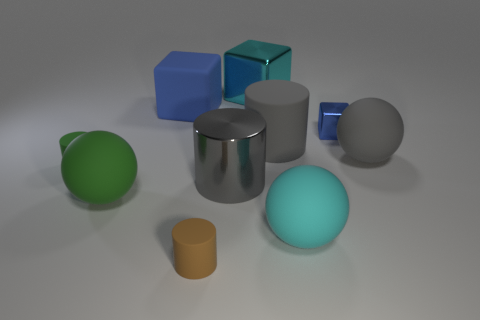Subtract all rubber cylinders. How many cylinders are left? 1 Subtract all green cylinders. How many cylinders are left? 3 Subtract all spheres. How many objects are left? 7 Subtract all purple blocks. How many cyan cylinders are left? 0 Subtract all rubber cubes. Subtract all big shiny cylinders. How many objects are left? 8 Add 9 gray shiny things. How many gray shiny things are left? 10 Add 1 large cyan blocks. How many large cyan blocks exist? 2 Subtract 0 blue spheres. How many objects are left? 10 Subtract 2 spheres. How many spheres are left? 1 Subtract all green cubes. Subtract all purple cylinders. How many cubes are left? 3 